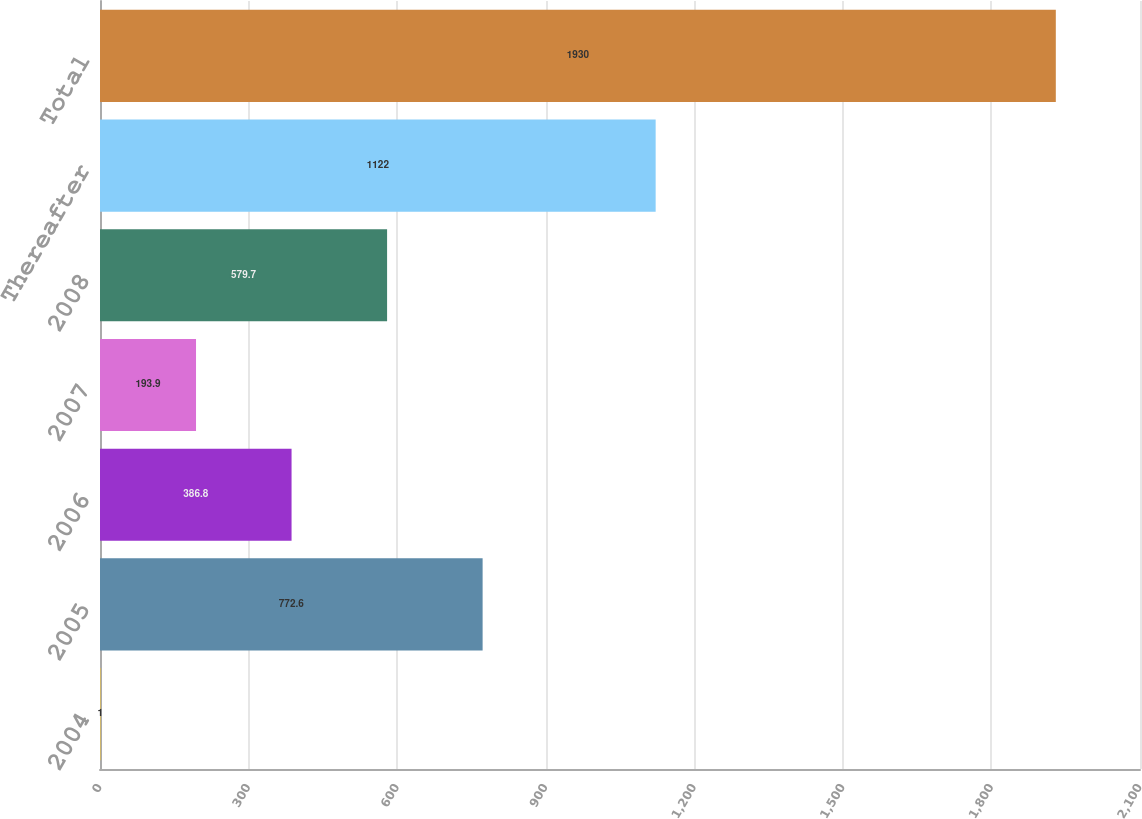<chart> <loc_0><loc_0><loc_500><loc_500><bar_chart><fcel>2004<fcel>2005<fcel>2006<fcel>2007<fcel>2008<fcel>Thereafter<fcel>Total<nl><fcel>1<fcel>772.6<fcel>386.8<fcel>193.9<fcel>579.7<fcel>1122<fcel>1930<nl></chart> 